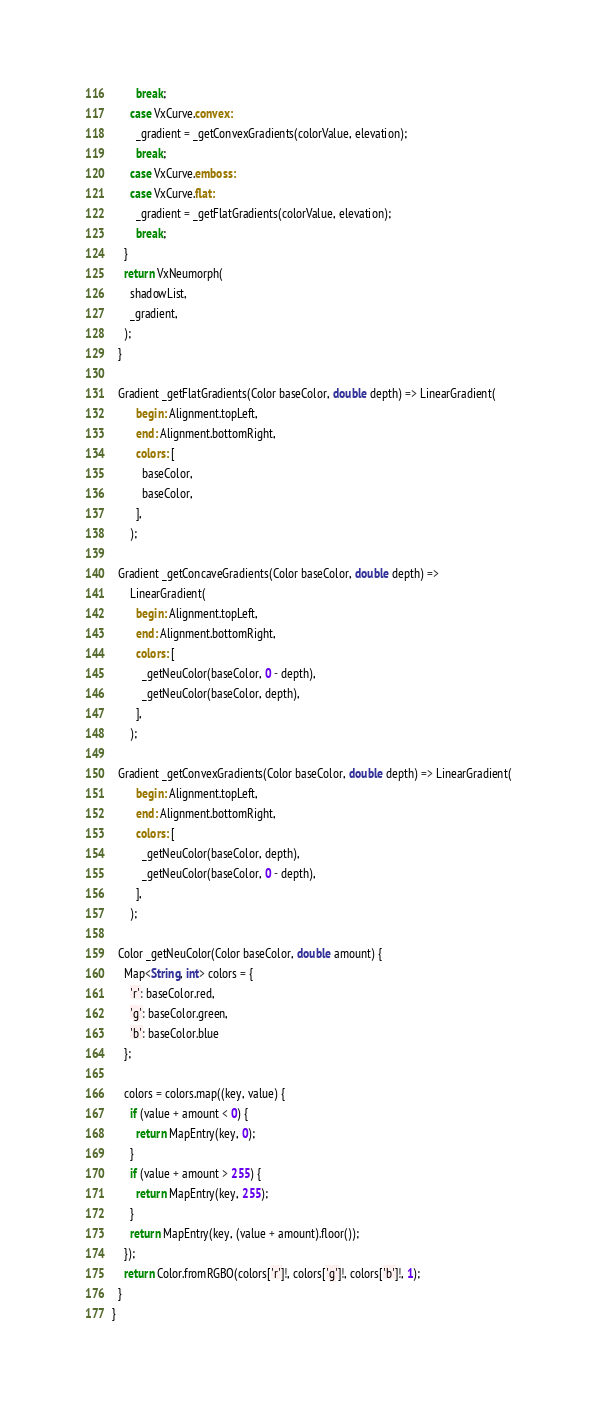<code> <loc_0><loc_0><loc_500><loc_500><_Dart_>        break;
      case VxCurve.convex:
        _gradient = _getConvexGradients(colorValue, elevation);
        break;
      case VxCurve.emboss:
      case VxCurve.flat:
        _gradient = _getFlatGradients(colorValue, elevation);
        break;
    }
    return VxNeumorph(
      shadowList,
      _gradient,
    );
  }

  Gradient _getFlatGradients(Color baseColor, double depth) => LinearGradient(
        begin: Alignment.topLeft,
        end: Alignment.bottomRight,
        colors: [
          baseColor,
          baseColor,
        ],
      );

  Gradient _getConcaveGradients(Color baseColor, double depth) =>
      LinearGradient(
        begin: Alignment.topLeft,
        end: Alignment.bottomRight,
        colors: [
          _getNeuColor(baseColor, 0 - depth),
          _getNeuColor(baseColor, depth),
        ],
      );

  Gradient _getConvexGradients(Color baseColor, double depth) => LinearGradient(
        begin: Alignment.topLeft,
        end: Alignment.bottomRight,
        colors: [
          _getNeuColor(baseColor, depth),
          _getNeuColor(baseColor, 0 - depth),
        ],
      );

  Color _getNeuColor(Color baseColor, double amount) {
    Map<String, int> colors = {
      'r': baseColor.red,
      'g': baseColor.green,
      'b': baseColor.blue
    };

    colors = colors.map((key, value) {
      if (value + amount < 0) {
        return MapEntry(key, 0);
      }
      if (value + amount > 255) {
        return MapEntry(key, 255);
      }
      return MapEntry(key, (value + amount).floor());
    });
    return Color.fromRGBO(colors['r']!, colors['g']!, colors['b']!, 1);
  }
}
</code> 